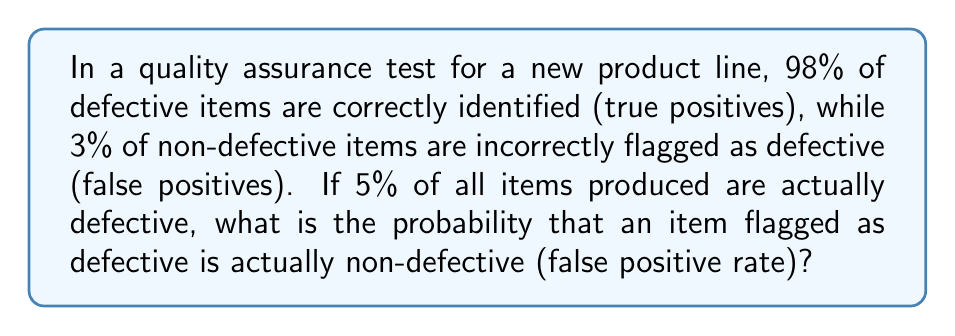Teach me how to tackle this problem. Let's approach this step-by-step using Bayes' Theorem:

1) Define events:
   D: Item is defective
   F: Item is flagged as defective

2) Given information:
   P(F|D) = 0.98 (sensitivity)
   P(F|not D) = 0.03 (false positive rate)
   P(D) = 0.05 (prevalence of defective items)

3) We want to find P(not D|F), the probability that an item is not defective given that it was flagged as defective.

4) Using Bayes' Theorem:
   $$P(\text{not D}|F) = \frac{P(F|\text{not D}) \cdot P(\text{not D})}{P(F)}$$

5) Calculate P(not D):
   P(not D) = 1 - P(D) = 1 - 0.05 = 0.95

6) Calculate P(F) using the law of total probability:
   $$P(F) = P(F|D) \cdot P(D) + P(F|\text{not D}) \cdot P(\text{not D})$$
   $$P(F) = 0.98 \cdot 0.05 + 0.03 \cdot 0.95 = 0.049 + 0.0285 = 0.0775$$

7) Now we can calculate P(not D|F):
   $$P(\text{not D}|F) = \frac{0.03 \cdot 0.95}{0.0775} \approx 0.3677$$

8) Convert to percentage: 0.3677 * 100 ≈ 36.77%

Therefore, approximately 36.77% of items flagged as defective are actually non-defective.
Answer: 36.77% 